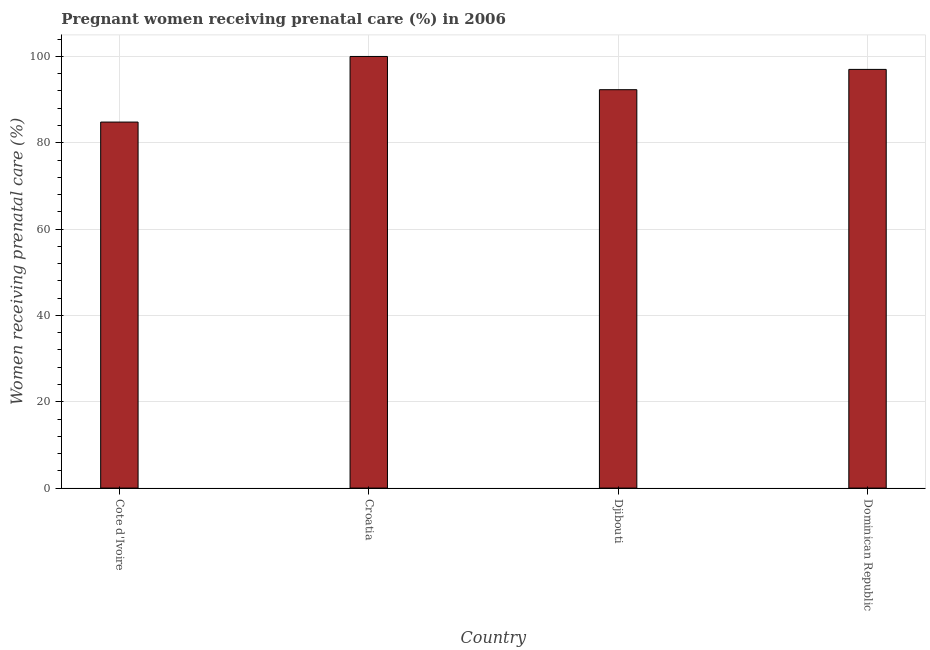Does the graph contain grids?
Provide a short and direct response. Yes. What is the title of the graph?
Your answer should be very brief. Pregnant women receiving prenatal care (%) in 2006. What is the label or title of the Y-axis?
Your answer should be very brief. Women receiving prenatal care (%). Across all countries, what is the maximum percentage of pregnant women receiving prenatal care?
Your answer should be very brief. 100. Across all countries, what is the minimum percentage of pregnant women receiving prenatal care?
Offer a very short reply. 84.8. In which country was the percentage of pregnant women receiving prenatal care maximum?
Offer a very short reply. Croatia. In which country was the percentage of pregnant women receiving prenatal care minimum?
Your answer should be very brief. Cote d'Ivoire. What is the sum of the percentage of pregnant women receiving prenatal care?
Make the answer very short. 374.1. What is the average percentage of pregnant women receiving prenatal care per country?
Give a very brief answer. 93.53. What is the median percentage of pregnant women receiving prenatal care?
Offer a very short reply. 94.65. In how many countries, is the percentage of pregnant women receiving prenatal care greater than 8 %?
Keep it short and to the point. 4. What is the ratio of the percentage of pregnant women receiving prenatal care in Cote d'Ivoire to that in Djibouti?
Offer a very short reply. 0.92. What is the difference between the highest and the second highest percentage of pregnant women receiving prenatal care?
Give a very brief answer. 3. In how many countries, is the percentage of pregnant women receiving prenatal care greater than the average percentage of pregnant women receiving prenatal care taken over all countries?
Give a very brief answer. 2. How many bars are there?
Offer a terse response. 4. Are all the bars in the graph horizontal?
Provide a succinct answer. No. How many countries are there in the graph?
Provide a succinct answer. 4. What is the Women receiving prenatal care (%) in Cote d'Ivoire?
Provide a succinct answer. 84.8. What is the Women receiving prenatal care (%) of Djibouti?
Your answer should be very brief. 92.3. What is the Women receiving prenatal care (%) in Dominican Republic?
Ensure brevity in your answer.  97. What is the difference between the Women receiving prenatal care (%) in Cote d'Ivoire and Croatia?
Keep it short and to the point. -15.2. What is the difference between the Women receiving prenatal care (%) in Cote d'Ivoire and Dominican Republic?
Offer a terse response. -12.2. What is the difference between the Women receiving prenatal care (%) in Croatia and Djibouti?
Your answer should be compact. 7.7. What is the difference between the Women receiving prenatal care (%) in Croatia and Dominican Republic?
Ensure brevity in your answer.  3. What is the difference between the Women receiving prenatal care (%) in Djibouti and Dominican Republic?
Provide a succinct answer. -4.7. What is the ratio of the Women receiving prenatal care (%) in Cote d'Ivoire to that in Croatia?
Offer a very short reply. 0.85. What is the ratio of the Women receiving prenatal care (%) in Cote d'Ivoire to that in Djibouti?
Offer a terse response. 0.92. What is the ratio of the Women receiving prenatal care (%) in Cote d'Ivoire to that in Dominican Republic?
Keep it short and to the point. 0.87. What is the ratio of the Women receiving prenatal care (%) in Croatia to that in Djibouti?
Offer a terse response. 1.08. What is the ratio of the Women receiving prenatal care (%) in Croatia to that in Dominican Republic?
Provide a succinct answer. 1.03. 